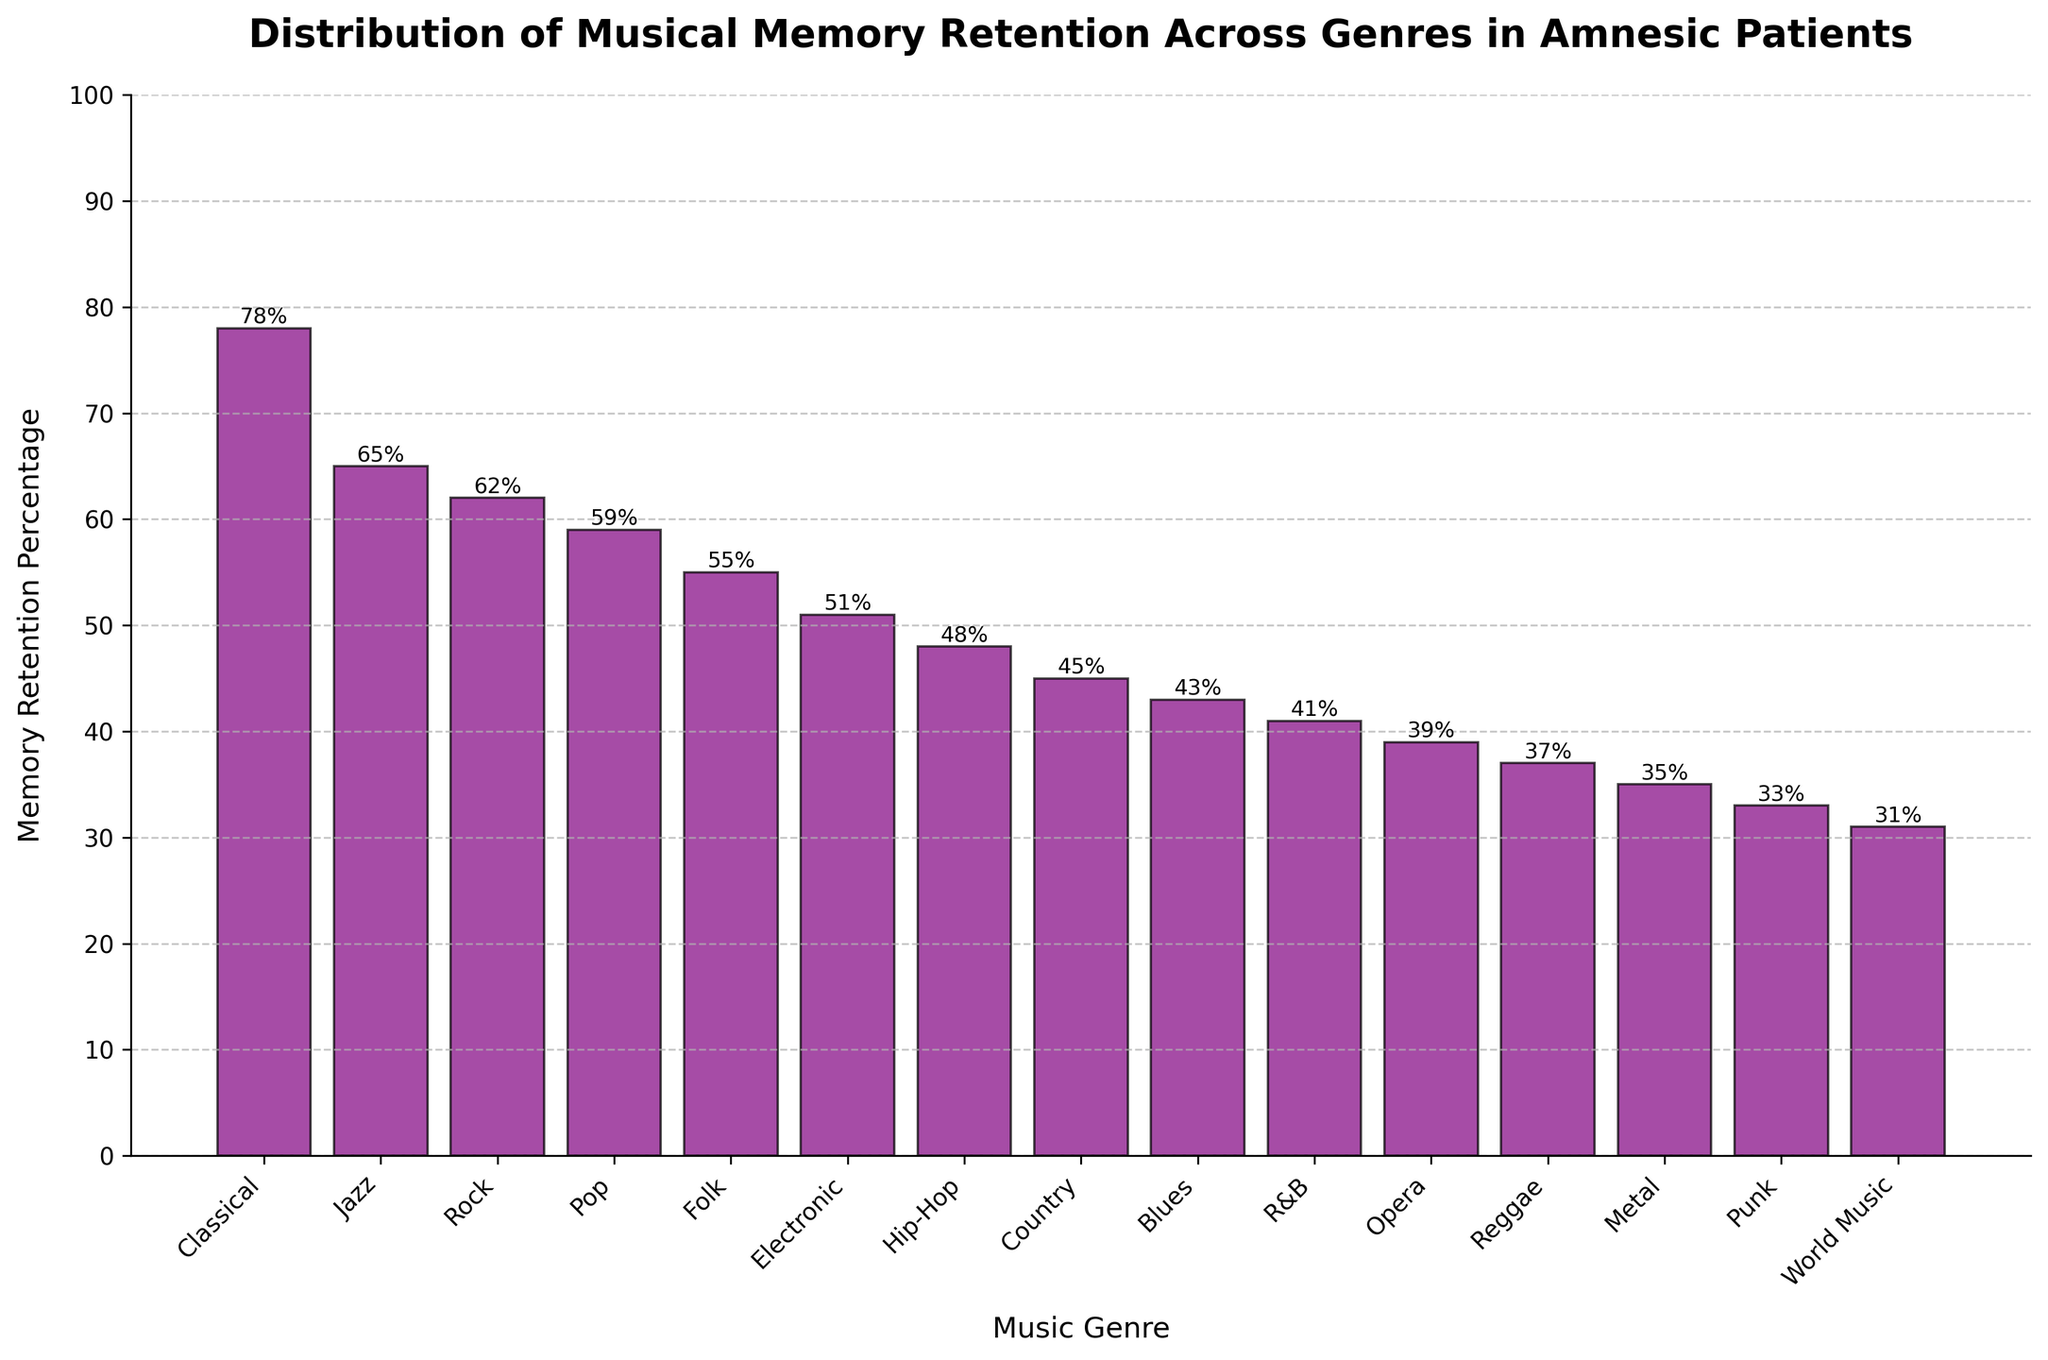Which music genre has the highest memory retention percentage in amnesic patients? By looking at the height of the bars, the bar representing Classical music is the tallest, indicating the highest memory retention percentage.
Answer: Classical Which music genre has the lowest memory retention percentage in amnesic patients? By examining the bar heights, World Music has the shortest bar, indicating the lowest memory retention percentage.
Answer: World Music How much higher is the memory retention percentage of Classical music compared to Punk? The memory retention percentage for Classical is 78%, while for Punk it is 33%. The difference is calculated by subtracting Punk's value from Classical's value: 78 - 33 = 45.
Answer: 45 What is the median memory retention percentage among the genres listed? To find the median, list the percentages in ascending order and identify the middle value. The ordered list is [31, 33, 35, 37, 39, 41, 43, 45, 48, 51, 55, 59, 62, 65, 78]. The middle value (8th in a list of 15) is 45, which is the memory retention percentage for Country.
Answer: 45 Which genre has a memory retention percentage closer to the median value: Electronic or Country? As we previously calculated, the median value is 45. Electronic has a percentage of 51 and Country has 45. Comparing their distances to the median (51-45 = 6 for Electronic and 45-45 = 0 for Country), Country is closer to the median.
Answer: Country How many genres have a memory retention percentage above 50%? Count the bars with percentages above 50%. The genres are Classical, Jazz, Rock, Pop, Folk, and Electronic, making it a total of 6 genres.
Answer: 6 Which genre has a memory retention percentage that is approximately half of the percentage for Rock music? Rock has a percentage of 62%. Half of 62 is 31. The genre closest to this value is World Music, with a percentage of 31.
Answer: World Music Are there more genres with memory retention percentages above 50% or below 50%? We previously identified 6 genres above 50%. There are 9 genres below 50% when you count the remaining genres. Thus, there are more genres below 50%.
Answer: Below 50% Which genres fall within 10 percentage points of each other, but have percentages on opposite sides of 50%? Look for pairs of genres where one is slightly above, and one slightly below 50%. Folk (55%) and Electronic (51%) fall within 10 percentage points but are both above 50%, so we need another pair. Hip-Hop (48%) and Electronic (51%) are within 10 points and on opposite sides of 50%.
Answer: Hip-Hop and Electronic 